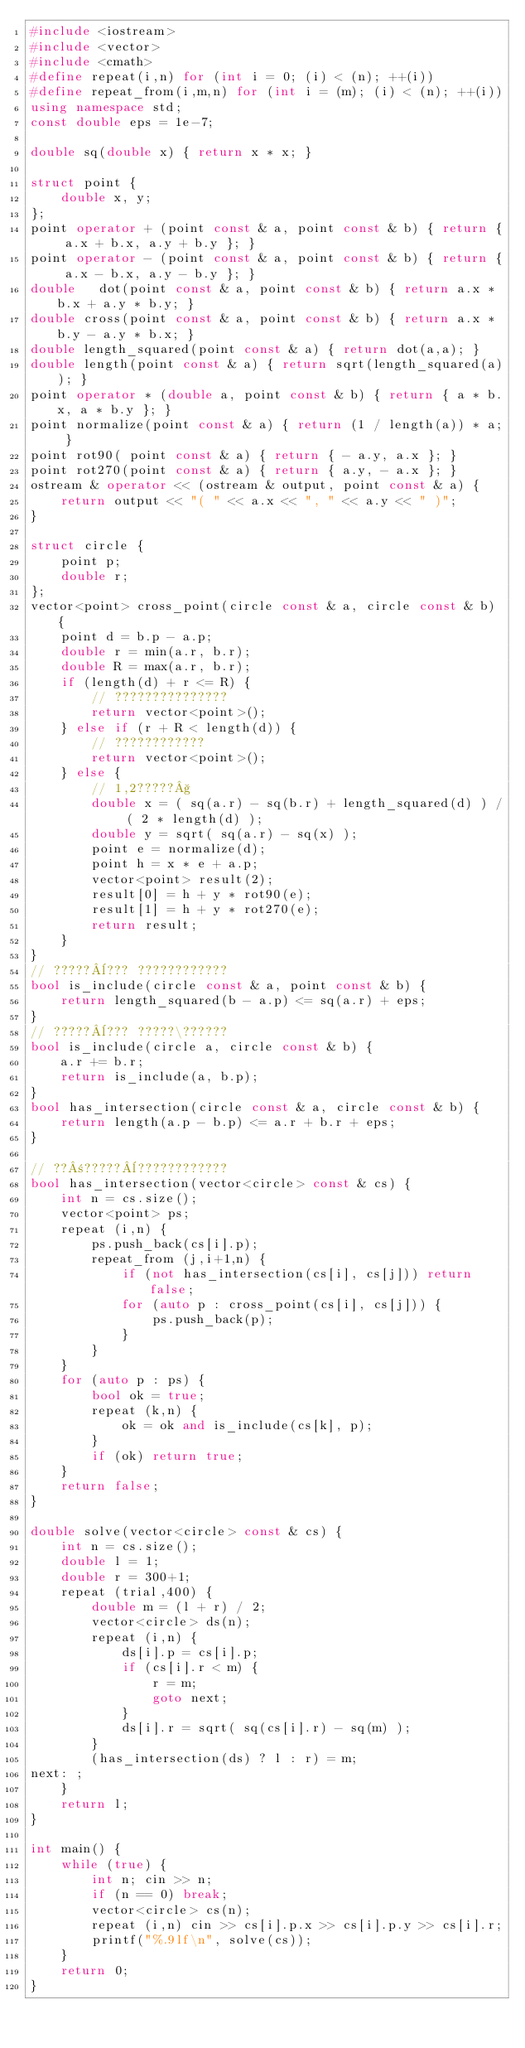<code> <loc_0><loc_0><loc_500><loc_500><_C++_>#include <iostream>
#include <vector>
#include <cmath>
#define repeat(i,n) for (int i = 0; (i) < (n); ++(i))
#define repeat_from(i,m,n) for (int i = (m); (i) < (n); ++(i))
using namespace std;
const double eps = 1e-7;

double sq(double x) { return x * x; }

struct point {
    double x, y;
};
point operator + (point const & a, point const & b) { return { a.x + b.x, a.y + b.y }; }
point operator - (point const & a, point const & b) { return { a.x - b.x, a.y - b.y }; }
double   dot(point const & a, point const & b) { return a.x * b.x + a.y * b.y; }
double cross(point const & a, point const & b) { return a.x * b.y - a.y * b.x; }
double length_squared(point const & a) { return dot(a,a); }
double length(point const & a) { return sqrt(length_squared(a)); }
point operator * (double a, point const & b) { return { a * b.x, a * b.y }; }
point normalize(point const & a) { return (1 / length(a)) * a; }
point rot90( point const & a) { return { - a.y, a.x }; }
point rot270(point const & a) { return { a.y, - a.x }; }
ostream & operator << (ostream & output, point const & a) {
    return output << "( " << a.x << ", " << a.y << " )";
}

struct circle {
    point p;
    double r;
};
vector<point> cross_point(circle const & a, circle const & b) {
    point d = b.p - a.p;
    double r = min(a.r, b.r);
    double R = max(a.r, b.r);
    if (length(d) + r <= R) {
        // ???????????????
        return vector<point>();
    } else if (r + R < length(d)) {
        // ????????????
        return vector<point>();
    } else {
        // 1,2?????§
        double x = ( sq(a.r) - sq(b.r) + length_squared(d) ) / ( 2 * length(d) );
        double y = sqrt( sq(a.r) - sq(x) );
        point e = normalize(d);
        point h = x * e + a.p;
        vector<point> result(2);
        result[0] = h + y * rot90(e);
        result[1] = h + y * rot270(e);
        return result;
    }
}
// ?????¨??? ????????????
bool is_include(circle const & a, point const & b) {
    return length_squared(b - a.p) <= sq(a.r) + eps;
}
// ?????¨??? ?????\??????
bool is_include(circle a, circle const & b) {
    a.r += b.r;
    return is_include(a, b.p);
}
bool has_intersection(circle const & a, circle const & b) {
    return length(a.p - b.p) <= a.r + b.r + eps;
}

// ??±?????¨????????????
bool has_intersection(vector<circle> const & cs) {
    int n = cs.size();
    vector<point> ps;
    repeat (i,n) {
        ps.push_back(cs[i].p);
        repeat_from (j,i+1,n) {
            if (not has_intersection(cs[i], cs[j])) return false;
            for (auto p : cross_point(cs[i], cs[j])) {
                ps.push_back(p);
            }
        }
    }
    for (auto p : ps) {
        bool ok = true;
        repeat (k,n) {
            ok = ok and is_include(cs[k], p);
        }
        if (ok) return true;
    }
    return false;
}

double solve(vector<circle> const & cs) {
    int n = cs.size();
    double l = 1;
    double r = 300+1;
    repeat (trial,400) {
        double m = (l + r) / 2;
        vector<circle> ds(n);
        repeat (i,n) {
            ds[i].p = cs[i].p;
            if (cs[i].r < m) {
                r = m;
                goto next;
            }
            ds[i].r = sqrt( sq(cs[i].r) - sq(m) );
        }
        (has_intersection(ds) ? l : r) = m;
next: ;
    }
    return l;
}

int main() {
    while (true) {
        int n; cin >> n;
        if (n == 0) break;
        vector<circle> cs(n);
        repeat (i,n) cin >> cs[i].p.x >> cs[i].p.y >> cs[i].r;
        printf("%.9lf\n", solve(cs));
    }
    return 0;
}</code> 